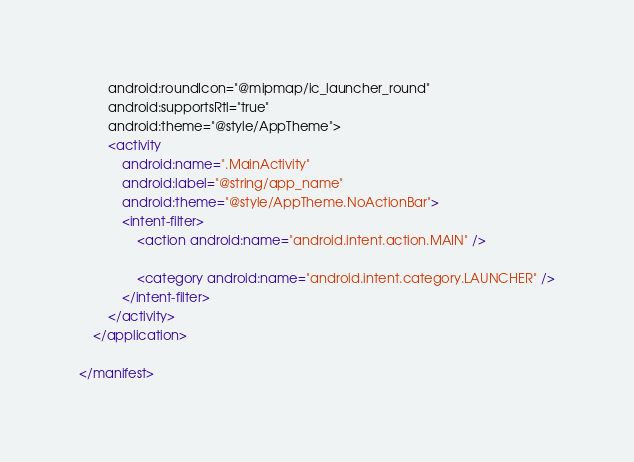Convert code to text. <code><loc_0><loc_0><loc_500><loc_500><_XML_>        android:roundIcon="@mipmap/ic_launcher_round"
        android:supportsRtl="true"
        android:theme="@style/AppTheme">
        <activity
            android:name=".MainActivity"
            android:label="@string/app_name"
            android:theme="@style/AppTheme.NoActionBar">
            <intent-filter>
                <action android:name="android.intent.action.MAIN" />

                <category android:name="android.intent.category.LAUNCHER" />
            </intent-filter>
        </activity>
    </application>

</manifest></code> 